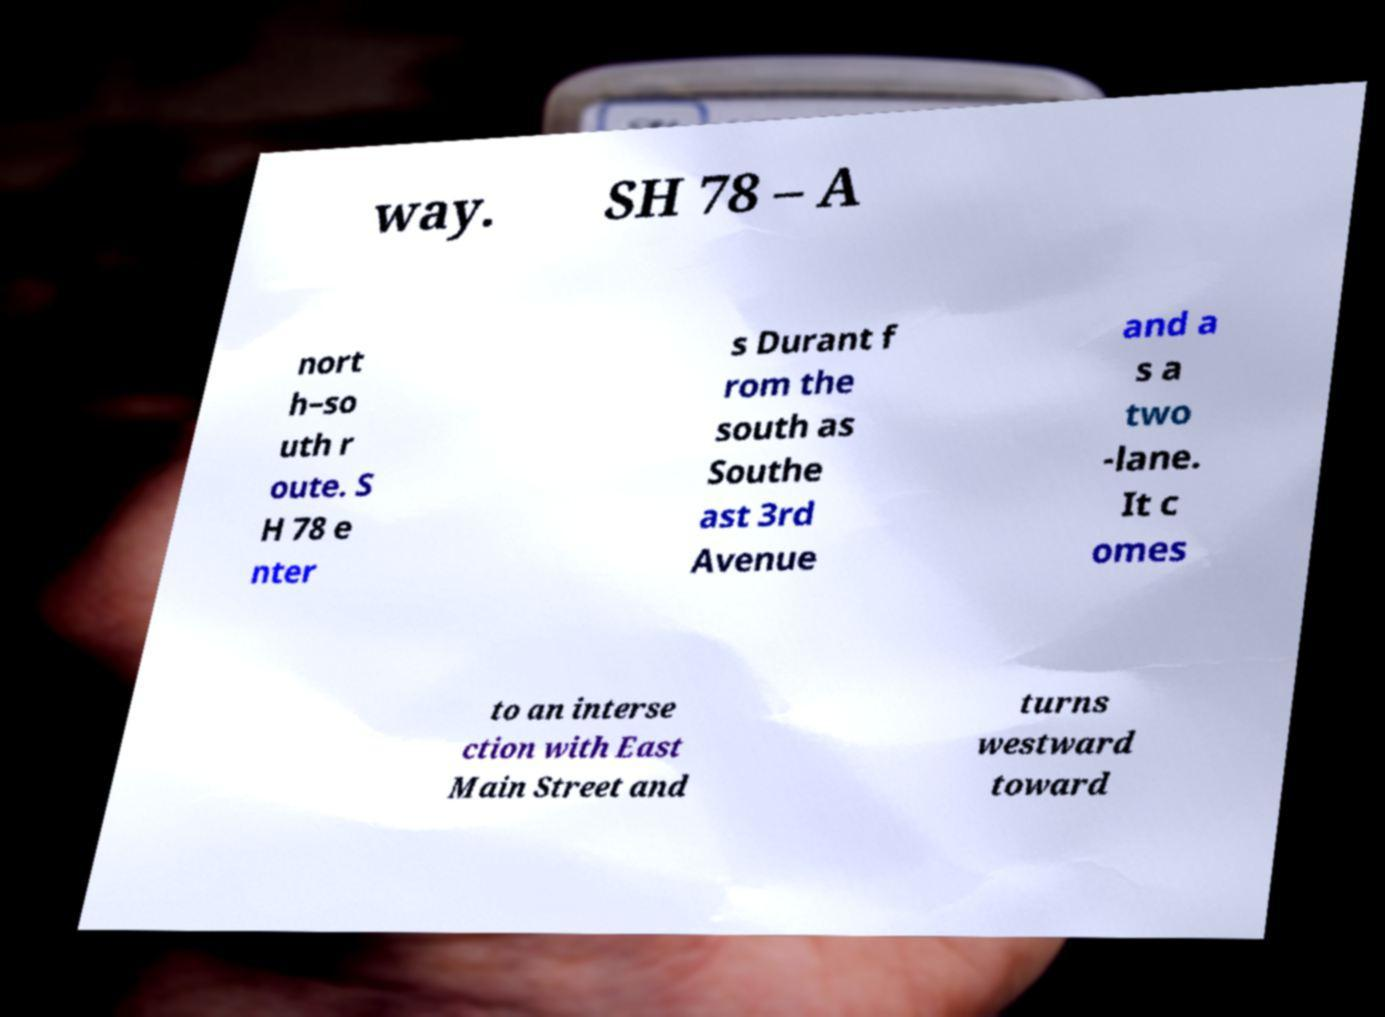Could you extract and type out the text from this image? way. SH 78 – A nort h–so uth r oute. S H 78 e nter s Durant f rom the south as Southe ast 3rd Avenue and a s a two -lane. It c omes to an interse ction with East Main Street and turns westward toward 